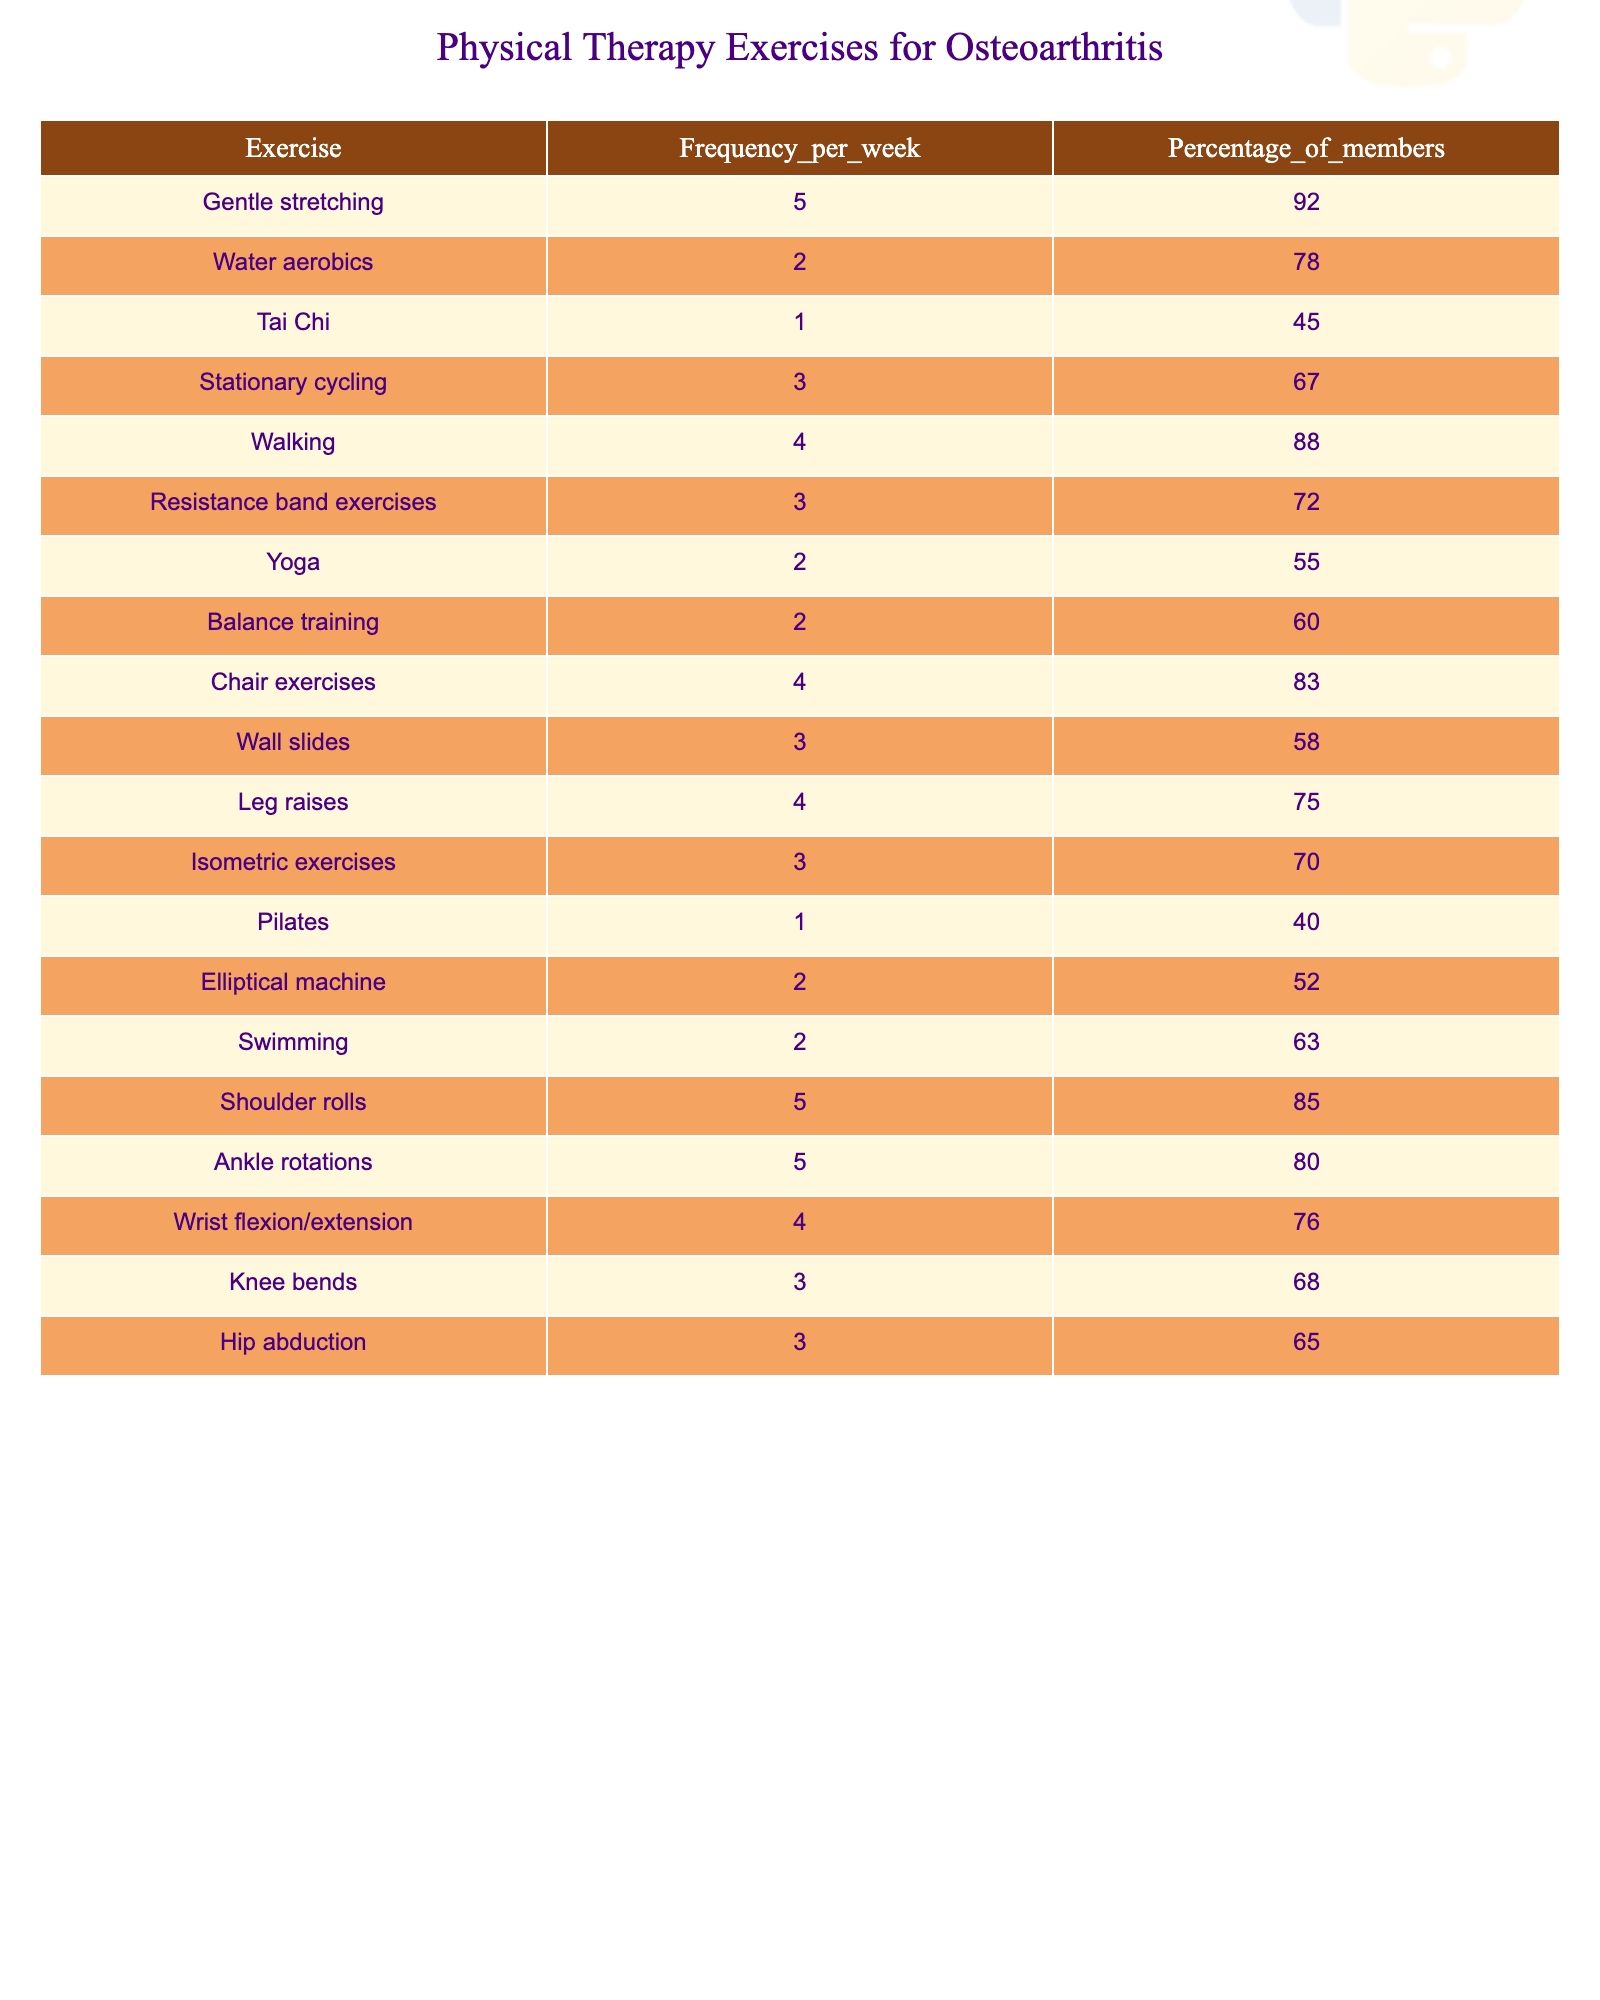What is the most frequently performed exercise among group members? The exercise with the highest frequency per week is "Gentle stretching," which is performed 5 times a week by 92% of members.
Answer: Gentle stretching How many exercises are performed 4 or more times per week? The exercises performed 4 or more times a week are "Gentle stretching," "Walking," "Chair exercises," and "Leg raises," totaling 4 exercises.
Answer: 4 What percentage of members perform Water aerobics? The table indicates that 78% of the members perform Water aerobics, as this is listed under the "Percentage_of_members" column for this exercise.
Answer: 78% Which exercises have a frequency of 2 times per week? The exercises listed with a frequency of 2 times per week are "Water aerobics," "Yoga," "Balance training," "Elliptical machine," and "Swimming," totaling 5 exercises.
Answer: 5 Is there any exercise that 100% of members perform? The table shows no exercise with a participation of 100%, as the highest percentage for any exercise is 92% for Gentle stretching.
Answer: No What is the average frequency of exercises performed by members? To find the average frequency, we add the frequencies (5 + 2 + 1 + 3 + 4 + 3 + 2 + 2 + 4 + 3 + 4 + 3 + 1 + 2 + 2 + 5 + 5 + 4 + 3 + 3 = 61) and divide by the number of exercises (20), resulting in an average of 3.05.
Answer: 3.05 What is the difference in frequency between the most and least performed exercises? The most performed exercise is "Gentle stretching" at 5 times per week and the least performed is "Tai Chi" at 1 time per week. The difference is 5 - 1 = 4.
Answer: 4 Do more members perform Isometric exercises compared to Tai Chi? Yes, 70% of members perform Isometric exercises compared to 45% who perform Tai Chi, confirming that more members do Isometric exercises.
Answer: Yes If a member does 3 different exercises each week, what percentage of exercises performed will be from Resistance band exercises and Knees bends combined? Resistance band exercises are done 3 times a week (72% participation) and Knee bends are also done 3 times a week (68% participation). Adding both percentages gives 72% + 68% = 140%.
Answer: 140% Which exercise has the lowest percentage of members performing it? The exercise with the lowest percentage is "Pilates," with only 40% of members participating.
Answer: Pilates 